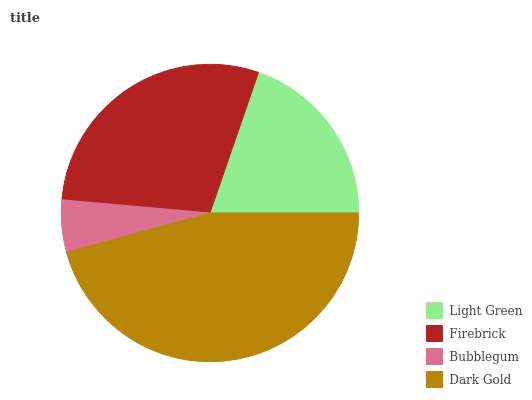Is Bubblegum the minimum?
Answer yes or no. Yes. Is Dark Gold the maximum?
Answer yes or no. Yes. Is Firebrick the minimum?
Answer yes or no. No. Is Firebrick the maximum?
Answer yes or no. No. Is Firebrick greater than Light Green?
Answer yes or no. Yes. Is Light Green less than Firebrick?
Answer yes or no. Yes. Is Light Green greater than Firebrick?
Answer yes or no. No. Is Firebrick less than Light Green?
Answer yes or no. No. Is Firebrick the high median?
Answer yes or no. Yes. Is Light Green the low median?
Answer yes or no. Yes. Is Light Green the high median?
Answer yes or no. No. Is Bubblegum the low median?
Answer yes or no. No. 